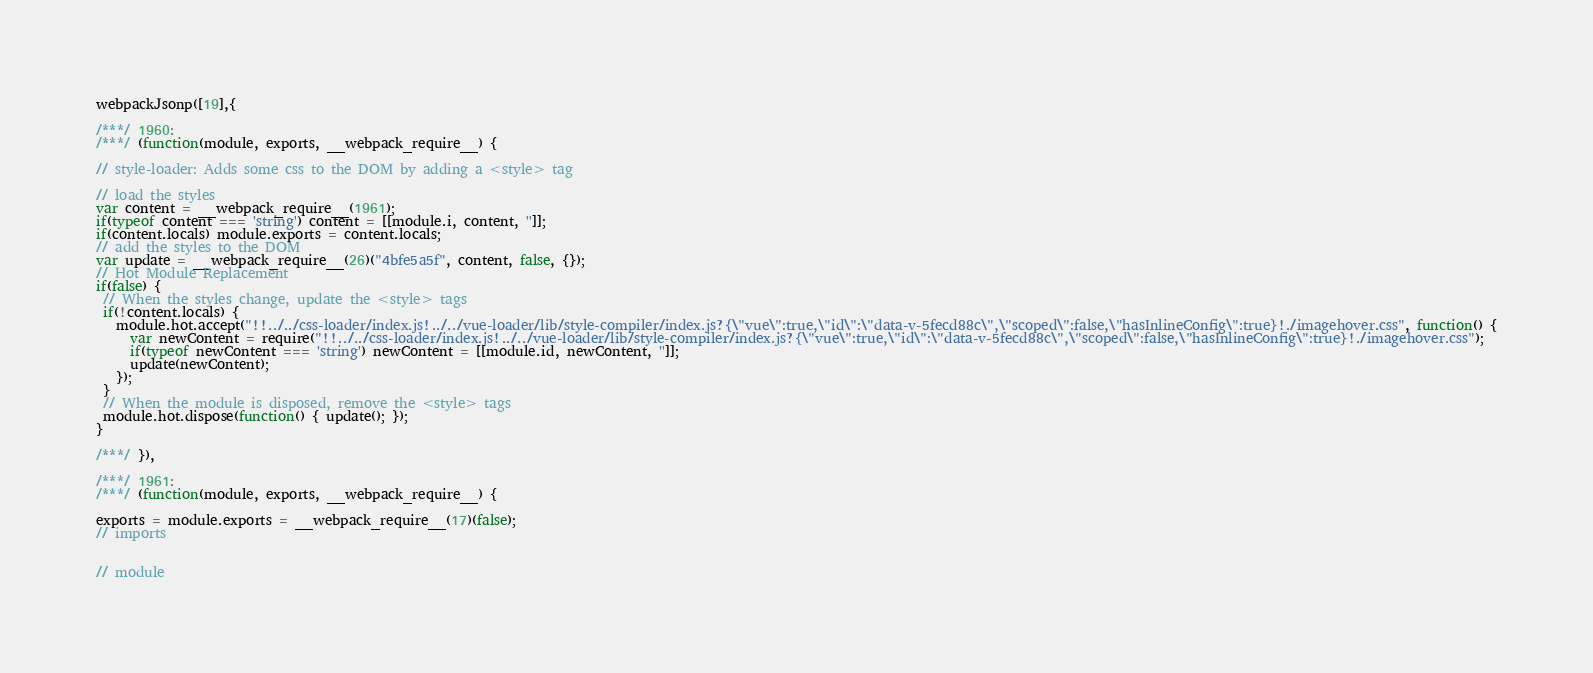<code> <loc_0><loc_0><loc_500><loc_500><_JavaScript_>webpackJsonp([19],{

/***/ 1960:
/***/ (function(module, exports, __webpack_require__) {

// style-loader: Adds some css to the DOM by adding a <style> tag

// load the styles
var content = __webpack_require__(1961);
if(typeof content === 'string') content = [[module.i, content, '']];
if(content.locals) module.exports = content.locals;
// add the styles to the DOM
var update = __webpack_require__(26)("4bfe5a5f", content, false, {});
// Hot Module Replacement
if(false) {
 // When the styles change, update the <style> tags
 if(!content.locals) {
   module.hot.accept("!!../../css-loader/index.js!../../vue-loader/lib/style-compiler/index.js?{\"vue\":true,\"id\":\"data-v-5fecd88c\",\"scoped\":false,\"hasInlineConfig\":true}!./imagehover.css", function() {
     var newContent = require("!!../../css-loader/index.js!../../vue-loader/lib/style-compiler/index.js?{\"vue\":true,\"id\":\"data-v-5fecd88c\",\"scoped\":false,\"hasInlineConfig\":true}!./imagehover.css");
     if(typeof newContent === 'string') newContent = [[module.id, newContent, '']];
     update(newContent);
   });
 }
 // When the module is disposed, remove the <style> tags
 module.hot.dispose(function() { update(); });
}

/***/ }),

/***/ 1961:
/***/ (function(module, exports, __webpack_require__) {

exports = module.exports = __webpack_require__(17)(false);
// imports


// module</code> 